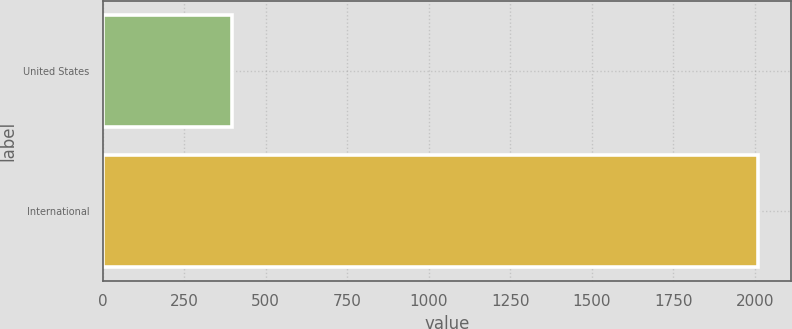Convert chart. <chart><loc_0><loc_0><loc_500><loc_500><bar_chart><fcel>United States<fcel>International<nl><fcel>396<fcel>2010<nl></chart> 